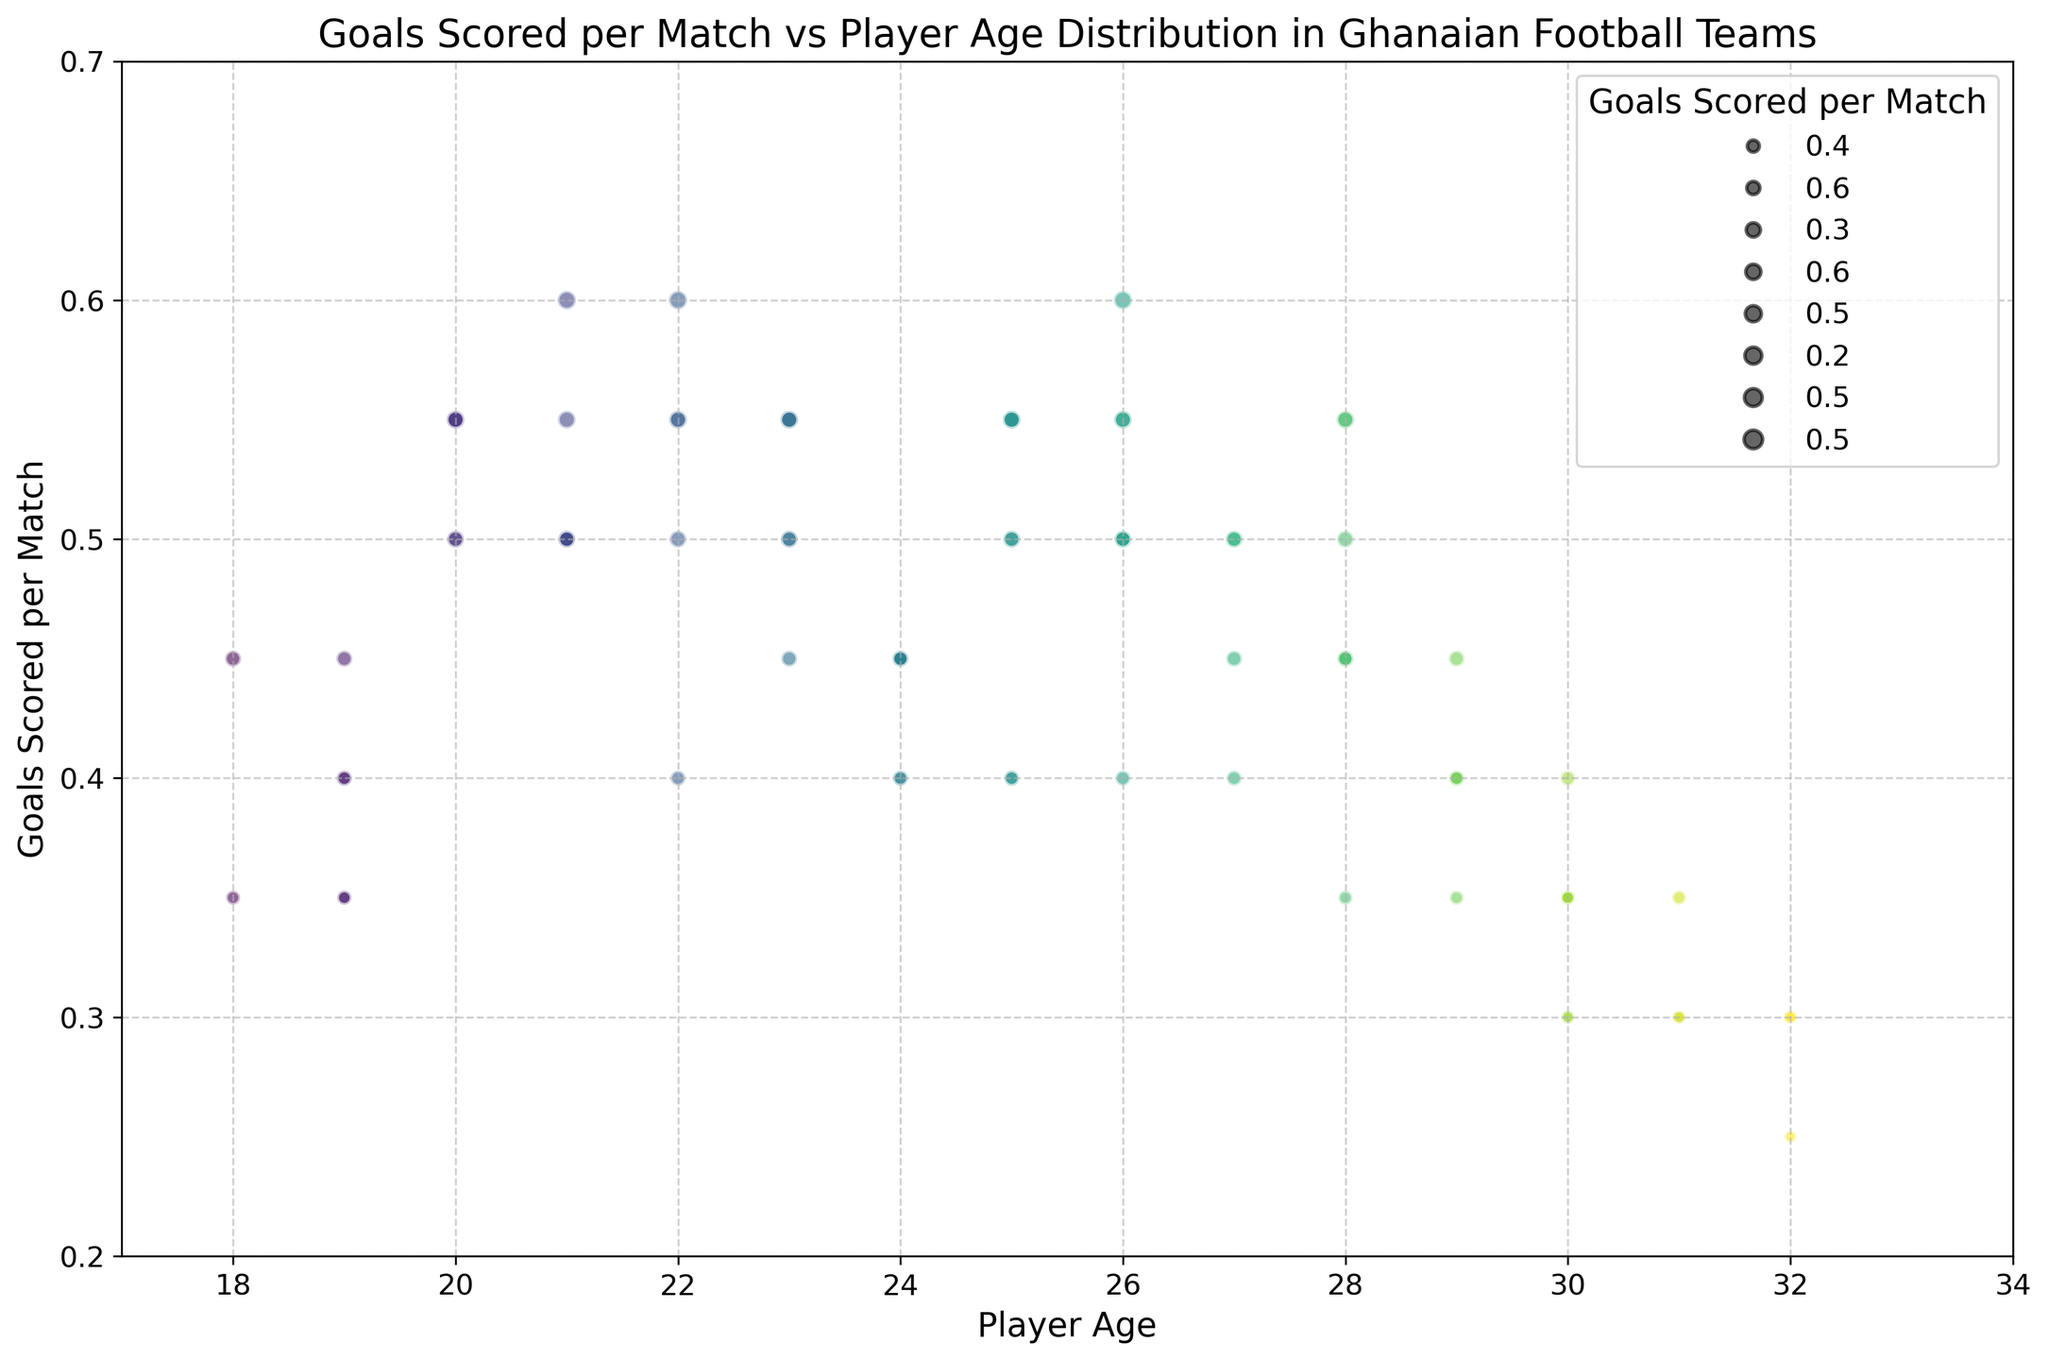What's the age range of players in the chart? Observe the x-axis range of the chart to determine the minimum and maximum player ages. The chart shows data points from age 18 to 32.
Answer: 18 to 32 Which player age group has the highest average goals scored per match? Inspect the chart for clusters of bubbles indicating player ages with higher goals scored per match. Ages around 21 have several larger bubbles (e.g., goals scored per match of 0.55 and above) indicating a higher average.
Answer: 21 Is there a correlation between player age and goals scored per match? Look at the overall trend of the bubbles in the chart. While specific ages (e.g., 21 and 26) show higher goals, there isn't a consistent trend for all ages suggesting a weak or no linear correlation.
Answer: Weak/No correlation Which player age has the largest bubble size, indicating the highest goal-scoring per match? The size of the bubbles indicates goals scored per match. The largest bubble sizes represent goals scored per match of 0.6. The ages with the largest bubbles are 22 and 21.
Answer: 22 and 21 Are there any player ages with multiple players having the same goals scored per match? Look for ages that have overlapping bubbles at the same vertical level. Ages 24 and 25 have multiple players scoring around 0.55 goals per match.
Answer: 24 and 25 What is the most common goal range among all players? Identify the vertical concentration of bubbles to see the most frequent goal ranges. Most bubbles are clustered between 0.4 and 0.55 goals scored per match.
Answer: 0.4 to 0.55 Do older players (age 30+) generally score more or less compared to younger players (age 20-25)? Compare the bubble sizes of players aged 30+ to those in the 20-25 age range. Generally, younger players (20-25) have larger bubbles indicating higher goals scored per match compared to older players (30+).
Answer: Less Which age group shows the widest variation in goals scored per match? Examine the spread of bubble sizes vertically for different ages. The age group 26 has varying bubble sizes ranging from 0.4 to 0.6, indicating a wide variation in goals scored per match.
Answer: 26 How many players aged 30 have a goals scored per match of 0.35? Look specifically at bubbles for age 30 and count the bubbles at or near the 0.35 goals scored per match level. There are three such players.
Answer: 3 